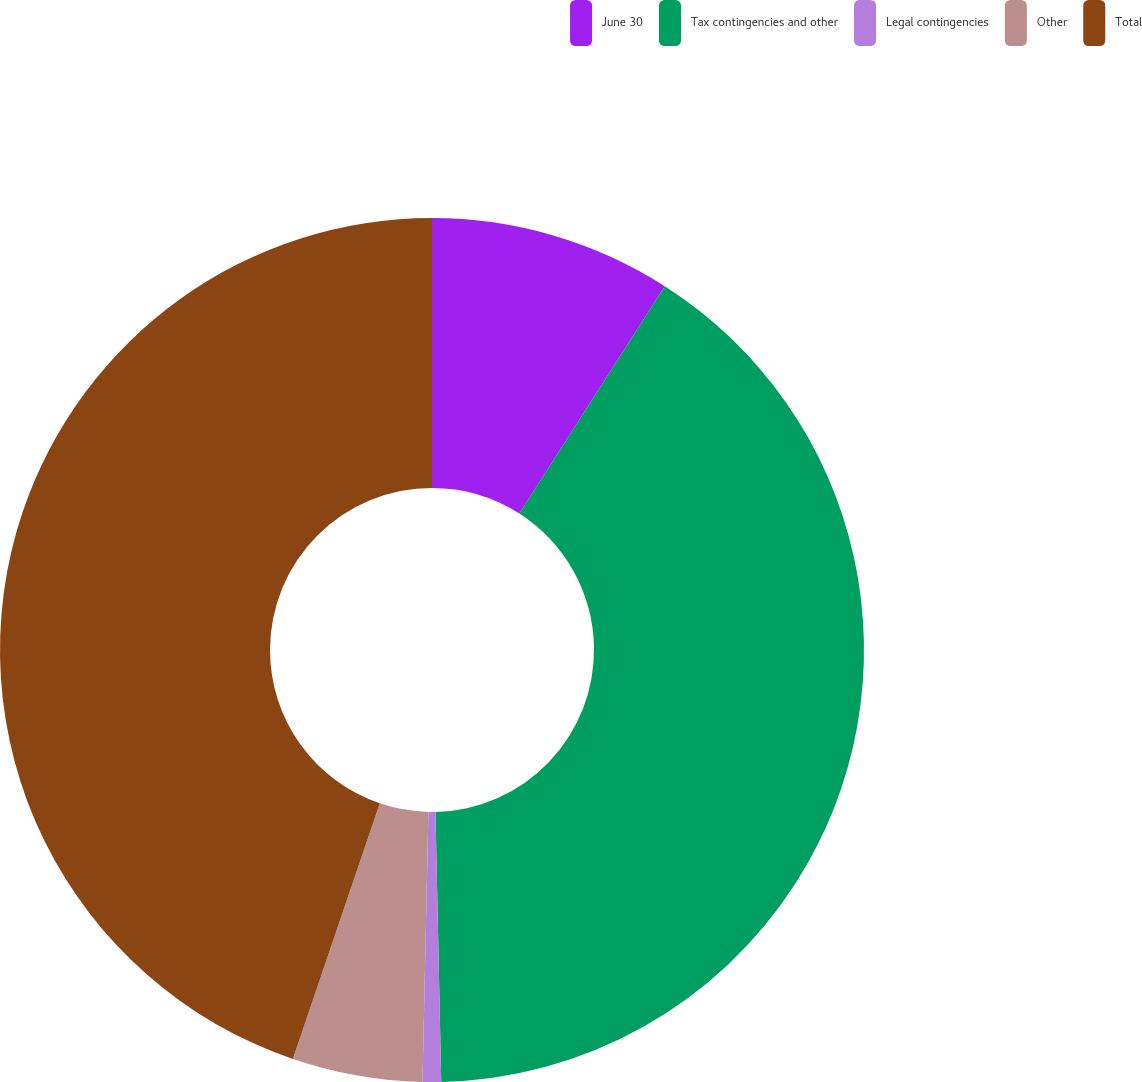Convert chart to OTSL. <chart><loc_0><loc_0><loc_500><loc_500><pie_chart><fcel>June 30<fcel>Tax contingencies and other<fcel>Legal contingencies<fcel>Other<fcel>Total<nl><fcel>9.06%<fcel>40.6%<fcel>0.69%<fcel>4.87%<fcel>44.78%<nl></chart> 